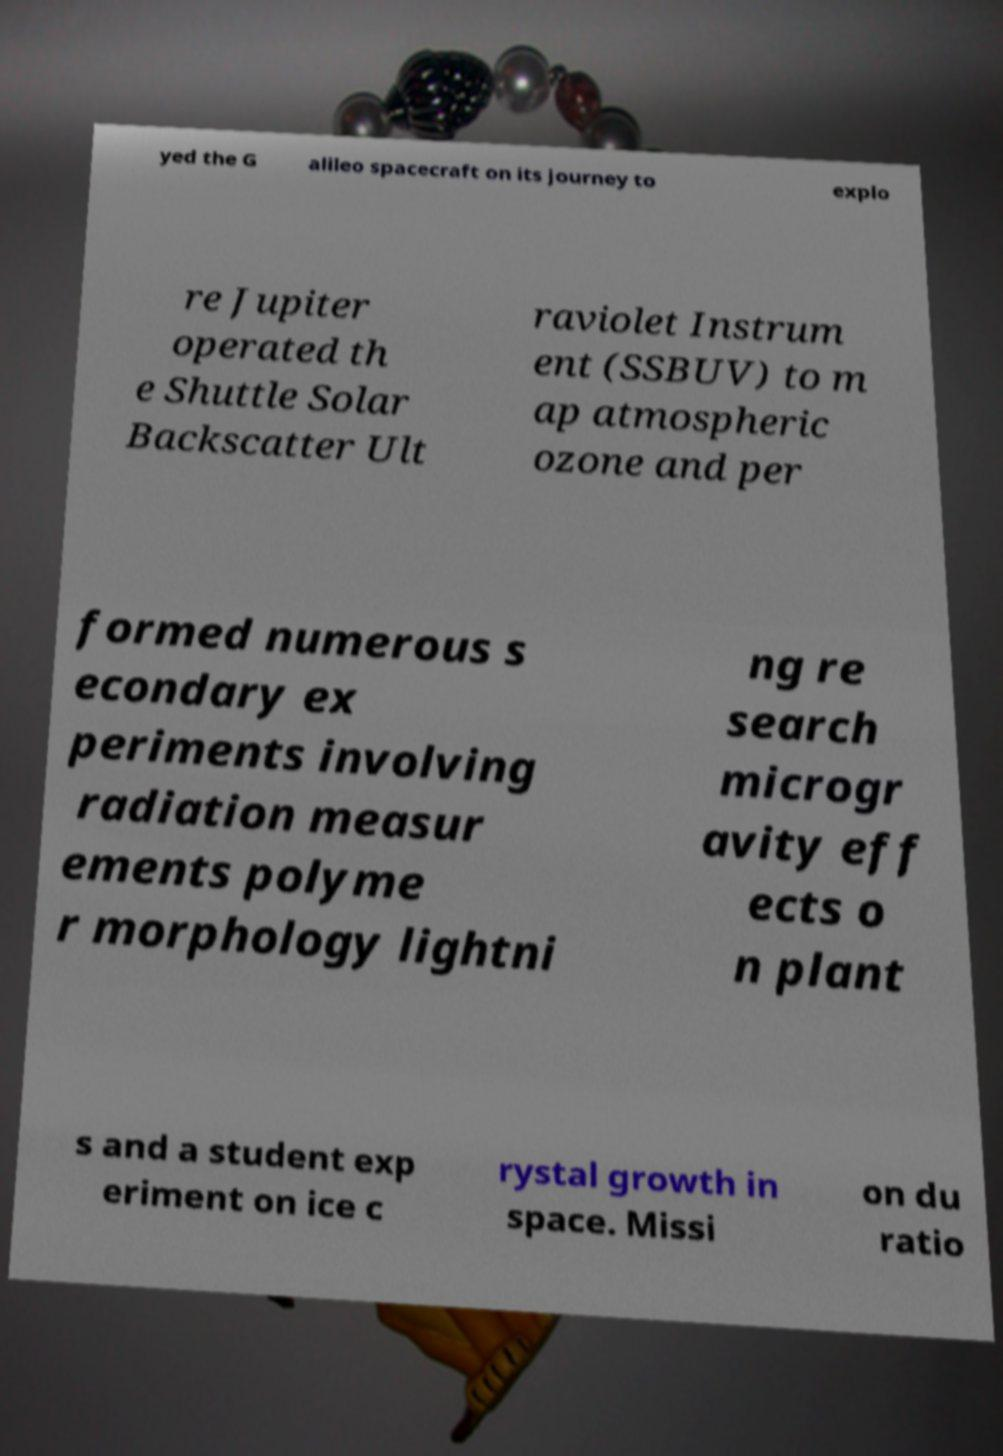Please identify and transcribe the text found in this image. yed the G alileo spacecraft on its journey to explo re Jupiter operated th e Shuttle Solar Backscatter Ult raviolet Instrum ent (SSBUV) to m ap atmospheric ozone and per formed numerous s econdary ex periments involving radiation measur ements polyme r morphology lightni ng re search microgr avity eff ects o n plant s and a student exp eriment on ice c rystal growth in space. Missi on du ratio 